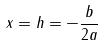Convert formula to latex. <formula><loc_0><loc_0><loc_500><loc_500>x = h = - \frac { b } { 2 a }</formula> 